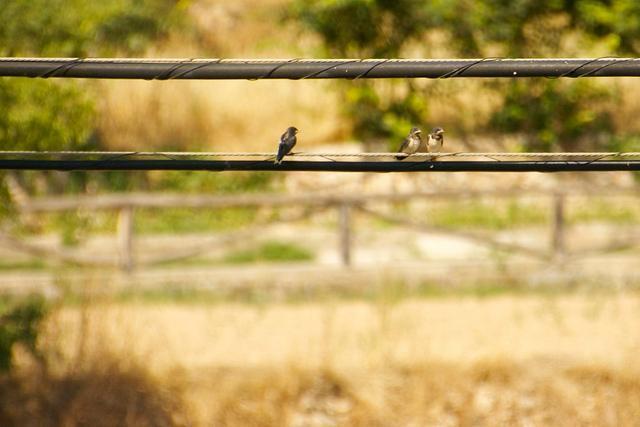How many birds are there?
Give a very brief answer. 3. 